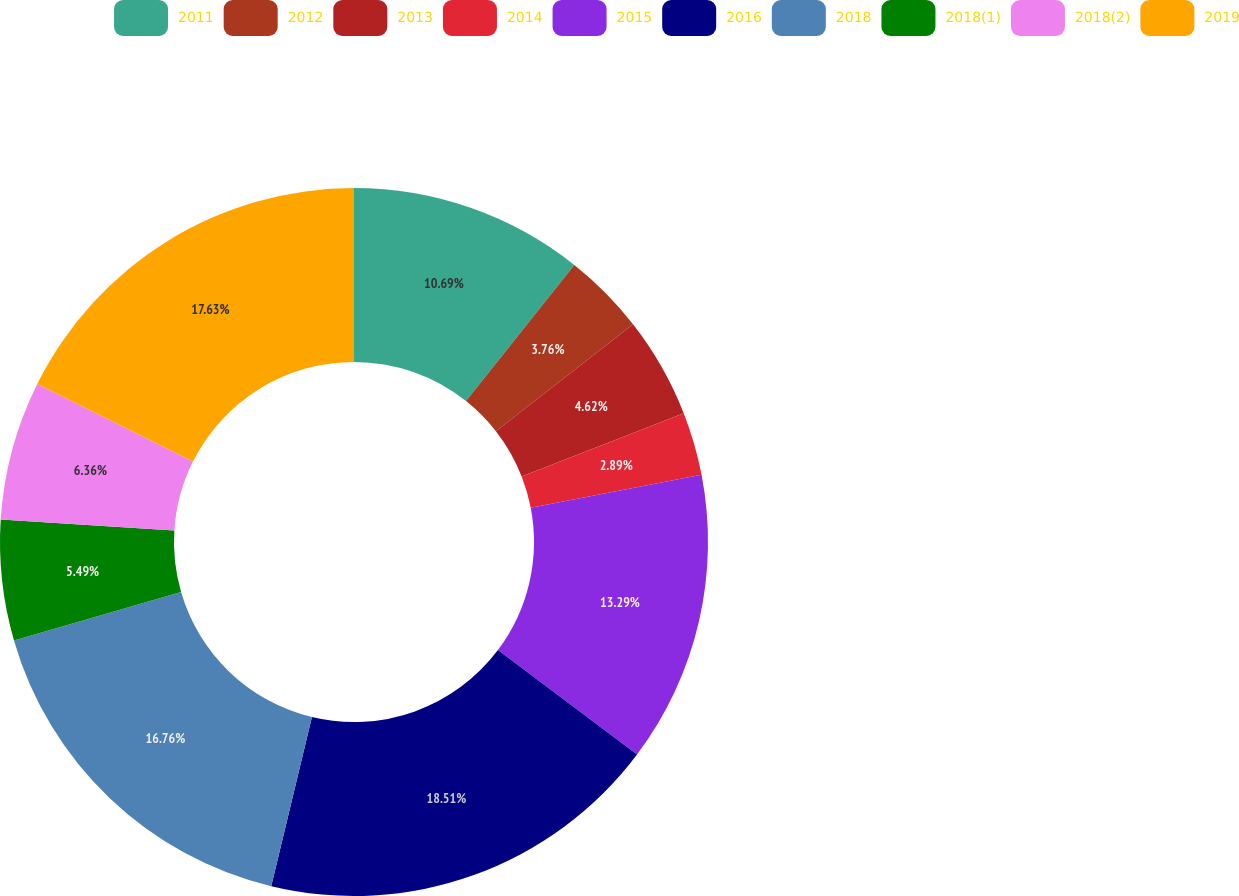Convert chart. <chart><loc_0><loc_0><loc_500><loc_500><pie_chart><fcel>2011<fcel>2012<fcel>2013<fcel>2014<fcel>2015<fcel>2016<fcel>2018<fcel>2018(1)<fcel>2018(2)<fcel>2019<nl><fcel>10.69%<fcel>3.76%<fcel>4.62%<fcel>2.89%<fcel>13.29%<fcel>18.5%<fcel>16.76%<fcel>5.49%<fcel>6.36%<fcel>17.63%<nl></chart> 